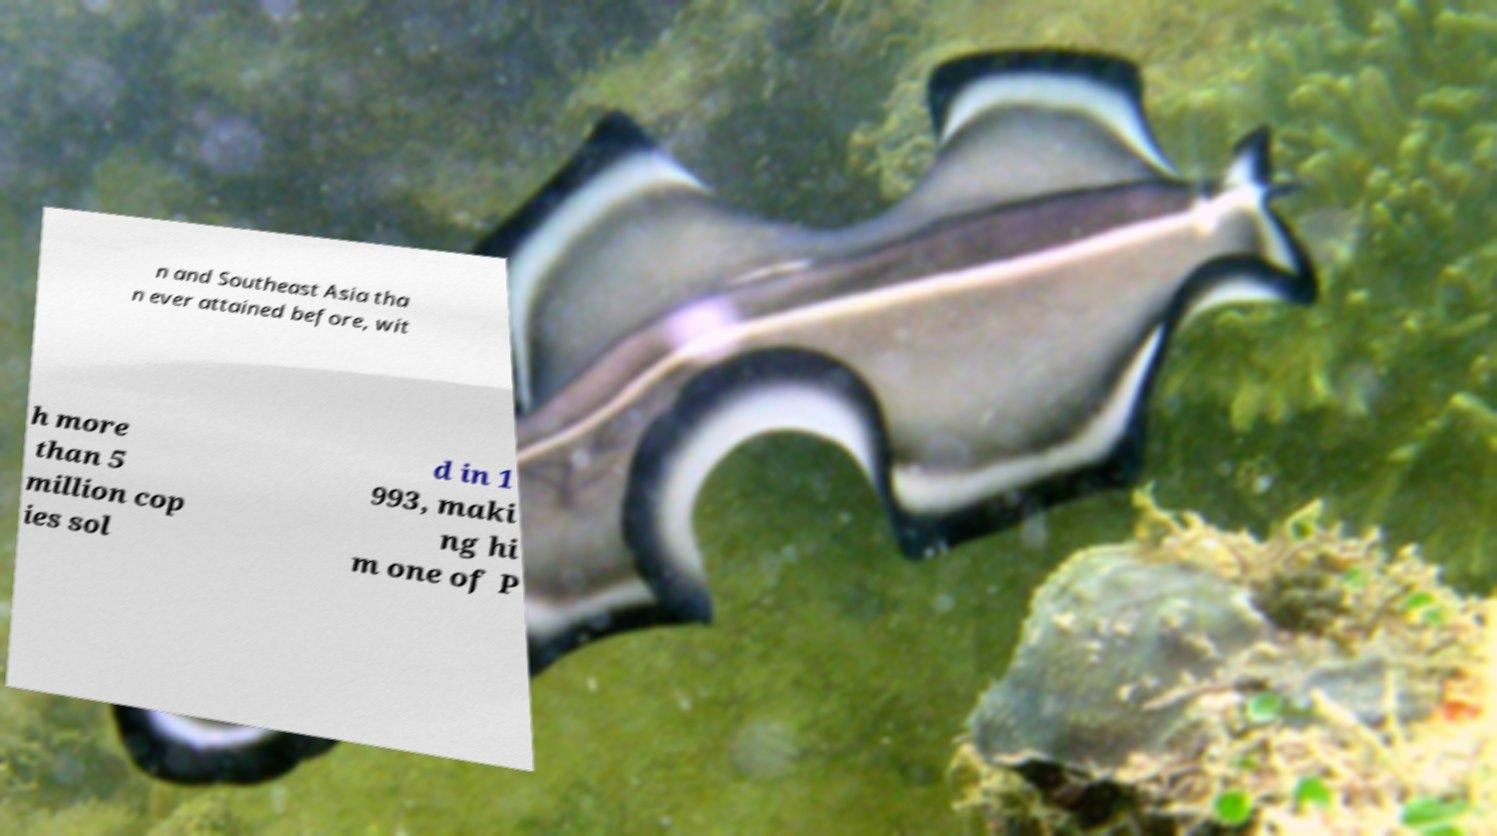Please identify and transcribe the text found in this image. n and Southeast Asia tha n ever attained before, wit h more than 5 million cop ies sol d in 1 993, maki ng hi m one of P 